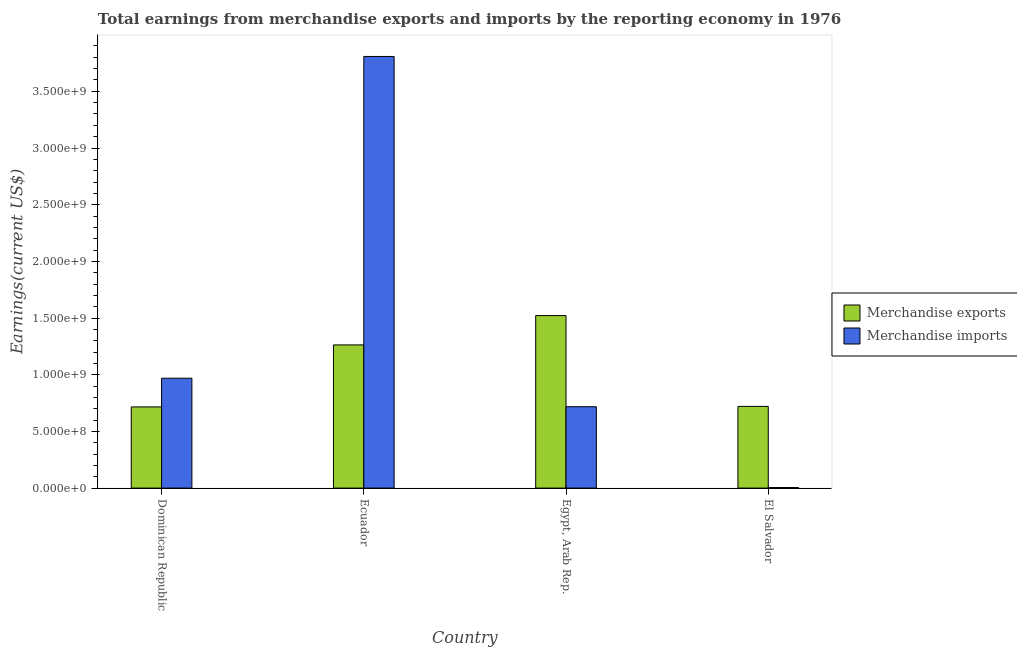How many different coloured bars are there?
Make the answer very short. 2. What is the label of the 3rd group of bars from the left?
Your answer should be very brief. Egypt, Arab Rep. What is the earnings from merchandise imports in Ecuador?
Provide a short and direct response. 3.81e+09. Across all countries, what is the maximum earnings from merchandise exports?
Offer a terse response. 1.52e+09. Across all countries, what is the minimum earnings from merchandise exports?
Keep it short and to the point. 7.16e+08. In which country was the earnings from merchandise imports maximum?
Keep it short and to the point. Ecuador. In which country was the earnings from merchandise exports minimum?
Give a very brief answer. Dominican Republic. What is the total earnings from merchandise imports in the graph?
Provide a succinct answer. 5.50e+09. What is the difference between the earnings from merchandise exports in Ecuador and that in Egypt, Arab Rep.?
Offer a terse response. -2.59e+08. What is the difference between the earnings from merchandise exports in El Salvador and the earnings from merchandise imports in Dominican Republic?
Provide a succinct answer. -2.48e+08. What is the average earnings from merchandise exports per country?
Your response must be concise. 1.06e+09. What is the difference between the earnings from merchandise exports and earnings from merchandise imports in El Salvador?
Offer a terse response. 7.16e+08. In how many countries, is the earnings from merchandise imports greater than 2700000000 US$?
Offer a very short reply. 1. What is the ratio of the earnings from merchandise exports in Dominican Republic to that in Ecuador?
Your answer should be very brief. 0.57. Is the difference between the earnings from merchandise exports in Dominican Republic and Egypt, Arab Rep. greater than the difference between the earnings from merchandise imports in Dominican Republic and Egypt, Arab Rep.?
Provide a short and direct response. No. What is the difference between the highest and the second highest earnings from merchandise exports?
Provide a succinct answer. 2.59e+08. What is the difference between the highest and the lowest earnings from merchandise exports?
Ensure brevity in your answer.  8.06e+08. Is the sum of the earnings from merchandise exports in Ecuador and El Salvador greater than the maximum earnings from merchandise imports across all countries?
Your answer should be very brief. No. What does the 2nd bar from the left in Egypt, Arab Rep. represents?
Offer a very short reply. Merchandise imports. Are all the bars in the graph horizontal?
Offer a very short reply. No. What is the difference between two consecutive major ticks on the Y-axis?
Your answer should be compact. 5.00e+08. Are the values on the major ticks of Y-axis written in scientific E-notation?
Ensure brevity in your answer.  Yes. Does the graph contain any zero values?
Offer a terse response. No. Does the graph contain grids?
Offer a terse response. No. Where does the legend appear in the graph?
Provide a short and direct response. Center right. How many legend labels are there?
Provide a succinct answer. 2. How are the legend labels stacked?
Your answer should be compact. Vertical. What is the title of the graph?
Your response must be concise. Total earnings from merchandise exports and imports by the reporting economy in 1976. What is the label or title of the X-axis?
Provide a short and direct response. Country. What is the label or title of the Y-axis?
Ensure brevity in your answer.  Earnings(current US$). What is the Earnings(current US$) of Merchandise exports in Dominican Republic?
Make the answer very short. 7.16e+08. What is the Earnings(current US$) in Merchandise imports in Dominican Republic?
Your answer should be compact. 9.69e+08. What is the Earnings(current US$) in Merchandise exports in Ecuador?
Offer a terse response. 1.26e+09. What is the Earnings(current US$) of Merchandise imports in Ecuador?
Give a very brief answer. 3.81e+09. What is the Earnings(current US$) of Merchandise exports in Egypt, Arab Rep.?
Give a very brief answer. 1.52e+09. What is the Earnings(current US$) in Merchandise imports in Egypt, Arab Rep.?
Make the answer very short. 7.18e+08. What is the Earnings(current US$) of Merchandise exports in El Salvador?
Provide a succinct answer. 7.21e+08. What is the Earnings(current US$) of Merchandise imports in El Salvador?
Provide a short and direct response. 4.78e+06. Across all countries, what is the maximum Earnings(current US$) in Merchandise exports?
Give a very brief answer. 1.52e+09. Across all countries, what is the maximum Earnings(current US$) in Merchandise imports?
Give a very brief answer. 3.81e+09. Across all countries, what is the minimum Earnings(current US$) in Merchandise exports?
Your answer should be compact. 7.16e+08. Across all countries, what is the minimum Earnings(current US$) of Merchandise imports?
Make the answer very short. 4.78e+06. What is the total Earnings(current US$) in Merchandise exports in the graph?
Provide a short and direct response. 4.22e+09. What is the total Earnings(current US$) in Merchandise imports in the graph?
Offer a terse response. 5.50e+09. What is the difference between the Earnings(current US$) of Merchandise exports in Dominican Republic and that in Ecuador?
Make the answer very short. -5.47e+08. What is the difference between the Earnings(current US$) in Merchandise imports in Dominican Republic and that in Ecuador?
Offer a terse response. -2.84e+09. What is the difference between the Earnings(current US$) in Merchandise exports in Dominican Republic and that in Egypt, Arab Rep.?
Provide a short and direct response. -8.06e+08. What is the difference between the Earnings(current US$) of Merchandise imports in Dominican Republic and that in Egypt, Arab Rep.?
Your response must be concise. 2.51e+08. What is the difference between the Earnings(current US$) in Merchandise exports in Dominican Republic and that in El Salvador?
Give a very brief answer. -4.57e+06. What is the difference between the Earnings(current US$) of Merchandise imports in Dominican Republic and that in El Salvador?
Provide a short and direct response. 9.64e+08. What is the difference between the Earnings(current US$) of Merchandise exports in Ecuador and that in Egypt, Arab Rep.?
Offer a very short reply. -2.59e+08. What is the difference between the Earnings(current US$) of Merchandise imports in Ecuador and that in Egypt, Arab Rep.?
Ensure brevity in your answer.  3.09e+09. What is the difference between the Earnings(current US$) of Merchandise exports in Ecuador and that in El Salvador?
Offer a very short reply. 5.42e+08. What is the difference between the Earnings(current US$) in Merchandise imports in Ecuador and that in El Salvador?
Your answer should be compact. 3.80e+09. What is the difference between the Earnings(current US$) of Merchandise exports in Egypt, Arab Rep. and that in El Salvador?
Provide a short and direct response. 8.01e+08. What is the difference between the Earnings(current US$) of Merchandise imports in Egypt, Arab Rep. and that in El Salvador?
Provide a succinct answer. 7.13e+08. What is the difference between the Earnings(current US$) in Merchandise exports in Dominican Republic and the Earnings(current US$) in Merchandise imports in Ecuador?
Offer a terse response. -3.09e+09. What is the difference between the Earnings(current US$) in Merchandise exports in Dominican Republic and the Earnings(current US$) in Merchandise imports in Egypt, Arab Rep.?
Make the answer very short. -1.72e+06. What is the difference between the Earnings(current US$) of Merchandise exports in Dominican Republic and the Earnings(current US$) of Merchandise imports in El Salvador?
Give a very brief answer. 7.11e+08. What is the difference between the Earnings(current US$) of Merchandise exports in Ecuador and the Earnings(current US$) of Merchandise imports in Egypt, Arab Rep.?
Give a very brief answer. 5.45e+08. What is the difference between the Earnings(current US$) of Merchandise exports in Ecuador and the Earnings(current US$) of Merchandise imports in El Salvador?
Give a very brief answer. 1.26e+09. What is the difference between the Earnings(current US$) of Merchandise exports in Egypt, Arab Rep. and the Earnings(current US$) of Merchandise imports in El Salvador?
Your answer should be very brief. 1.52e+09. What is the average Earnings(current US$) of Merchandise exports per country?
Give a very brief answer. 1.06e+09. What is the average Earnings(current US$) in Merchandise imports per country?
Provide a succinct answer. 1.37e+09. What is the difference between the Earnings(current US$) in Merchandise exports and Earnings(current US$) in Merchandise imports in Dominican Republic?
Keep it short and to the point. -2.53e+08. What is the difference between the Earnings(current US$) in Merchandise exports and Earnings(current US$) in Merchandise imports in Ecuador?
Keep it short and to the point. -2.54e+09. What is the difference between the Earnings(current US$) of Merchandise exports and Earnings(current US$) of Merchandise imports in Egypt, Arab Rep.?
Offer a terse response. 8.04e+08. What is the difference between the Earnings(current US$) of Merchandise exports and Earnings(current US$) of Merchandise imports in El Salvador?
Provide a succinct answer. 7.16e+08. What is the ratio of the Earnings(current US$) of Merchandise exports in Dominican Republic to that in Ecuador?
Your answer should be very brief. 0.57. What is the ratio of the Earnings(current US$) of Merchandise imports in Dominican Republic to that in Ecuador?
Offer a very short reply. 0.25. What is the ratio of the Earnings(current US$) in Merchandise exports in Dominican Republic to that in Egypt, Arab Rep.?
Provide a short and direct response. 0.47. What is the ratio of the Earnings(current US$) in Merchandise imports in Dominican Republic to that in Egypt, Arab Rep.?
Provide a short and direct response. 1.35. What is the ratio of the Earnings(current US$) in Merchandise exports in Dominican Republic to that in El Salvador?
Your answer should be very brief. 0.99. What is the ratio of the Earnings(current US$) in Merchandise imports in Dominican Republic to that in El Salvador?
Offer a terse response. 202.74. What is the ratio of the Earnings(current US$) in Merchandise exports in Ecuador to that in Egypt, Arab Rep.?
Ensure brevity in your answer.  0.83. What is the ratio of the Earnings(current US$) of Merchandise imports in Ecuador to that in Egypt, Arab Rep.?
Give a very brief answer. 5.3. What is the ratio of the Earnings(current US$) in Merchandise exports in Ecuador to that in El Salvador?
Your answer should be compact. 1.75. What is the ratio of the Earnings(current US$) in Merchandise imports in Ecuador to that in El Salvador?
Offer a terse response. 796.56. What is the ratio of the Earnings(current US$) in Merchandise exports in Egypt, Arab Rep. to that in El Salvador?
Give a very brief answer. 2.11. What is the ratio of the Earnings(current US$) in Merchandise imports in Egypt, Arab Rep. to that in El Salvador?
Offer a very short reply. 150.18. What is the difference between the highest and the second highest Earnings(current US$) of Merchandise exports?
Offer a terse response. 2.59e+08. What is the difference between the highest and the second highest Earnings(current US$) of Merchandise imports?
Your answer should be very brief. 2.84e+09. What is the difference between the highest and the lowest Earnings(current US$) of Merchandise exports?
Keep it short and to the point. 8.06e+08. What is the difference between the highest and the lowest Earnings(current US$) of Merchandise imports?
Provide a succinct answer. 3.80e+09. 